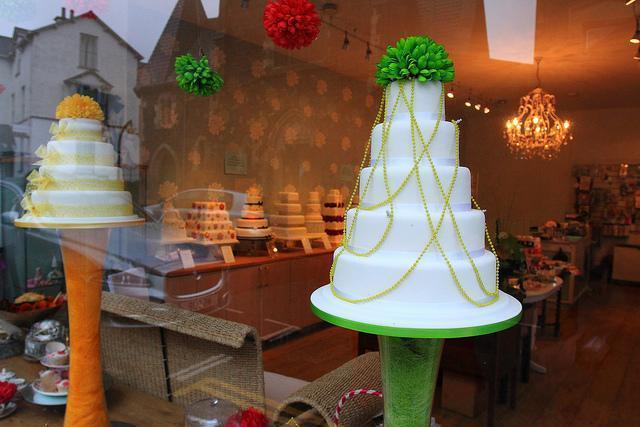How many cakes can you see?
Give a very brief answer. 2. 